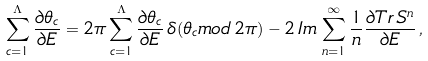Convert formula to latex. <formula><loc_0><loc_0><loc_500><loc_500>\sum _ { c = 1 } ^ { \Lambda } \frac { \partial \theta _ { c } } { \partial E } = 2 \pi \sum _ { c = 1 } ^ { \Lambda } \frac { \partial \theta _ { c } } { \partial E } \, \delta ( \theta _ { c } m o d \, 2 \pi ) - 2 \, I m \, \sum _ { n = 1 } ^ { \infty } \frac { 1 } { n } \frac { \partial T r \, S ^ { n } } { \partial E } \, ,</formula> 